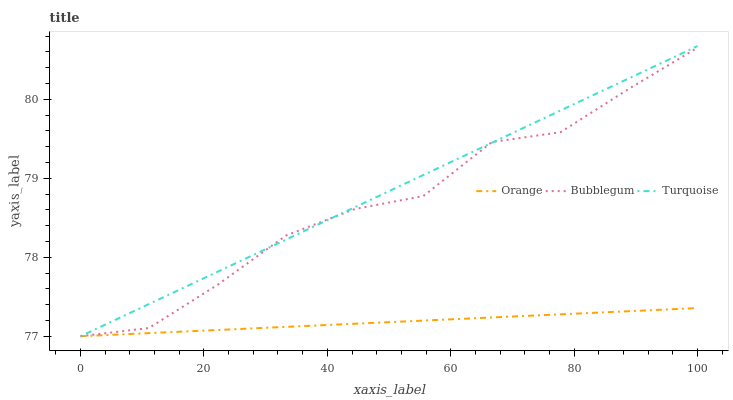Does Bubblegum have the minimum area under the curve?
Answer yes or no. No. Does Bubblegum have the maximum area under the curve?
Answer yes or no. No. Is Turquoise the smoothest?
Answer yes or no. No. Is Turquoise the roughest?
Answer yes or no. No. Does Bubblegum have the highest value?
Answer yes or no. No. 